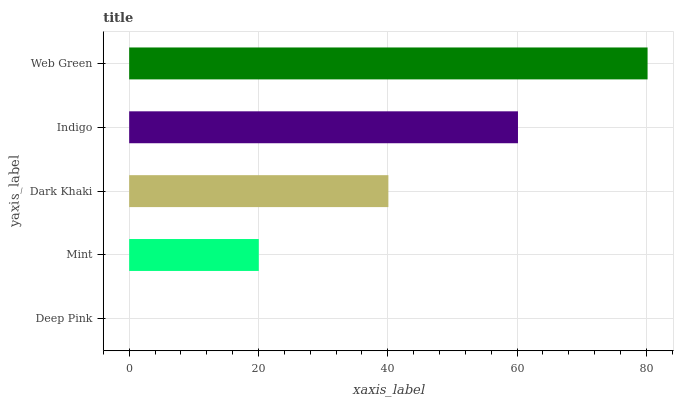Is Deep Pink the minimum?
Answer yes or no. Yes. Is Web Green the maximum?
Answer yes or no. Yes. Is Mint the minimum?
Answer yes or no. No. Is Mint the maximum?
Answer yes or no. No. Is Mint greater than Deep Pink?
Answer yes or no. Yes. Is Deep Pink less than Mint?
Answer yes or no. Yes. Is Deep Pink greater than Mint?
Answer yes or no. No. Is Mint less than Deep Pink?
Answer yes or no. No. Is Dark Khaki the high median?
Answer yes or no. Yes. Is Dark Khaki the low median?
Answer yes or no. Yes. Is Deep Pink the high median?
Answer yes or no. No. Is Web Green the low median?
Answer yes or no. No. 